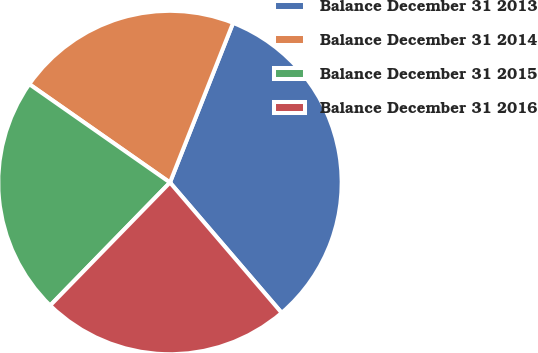<chart> <loc_0><loc_0><loc_500><loc_500><pie_chart><fcel>Balance December 31 2013<fcel>Balance December 31 2014<fcel>Balance December 31 2015<fcel>Balance December 31 2016<nl><fcel>32.73%<fcel>21.28%<fcel>22.42%<fcel>23.57%<nl></chart> 